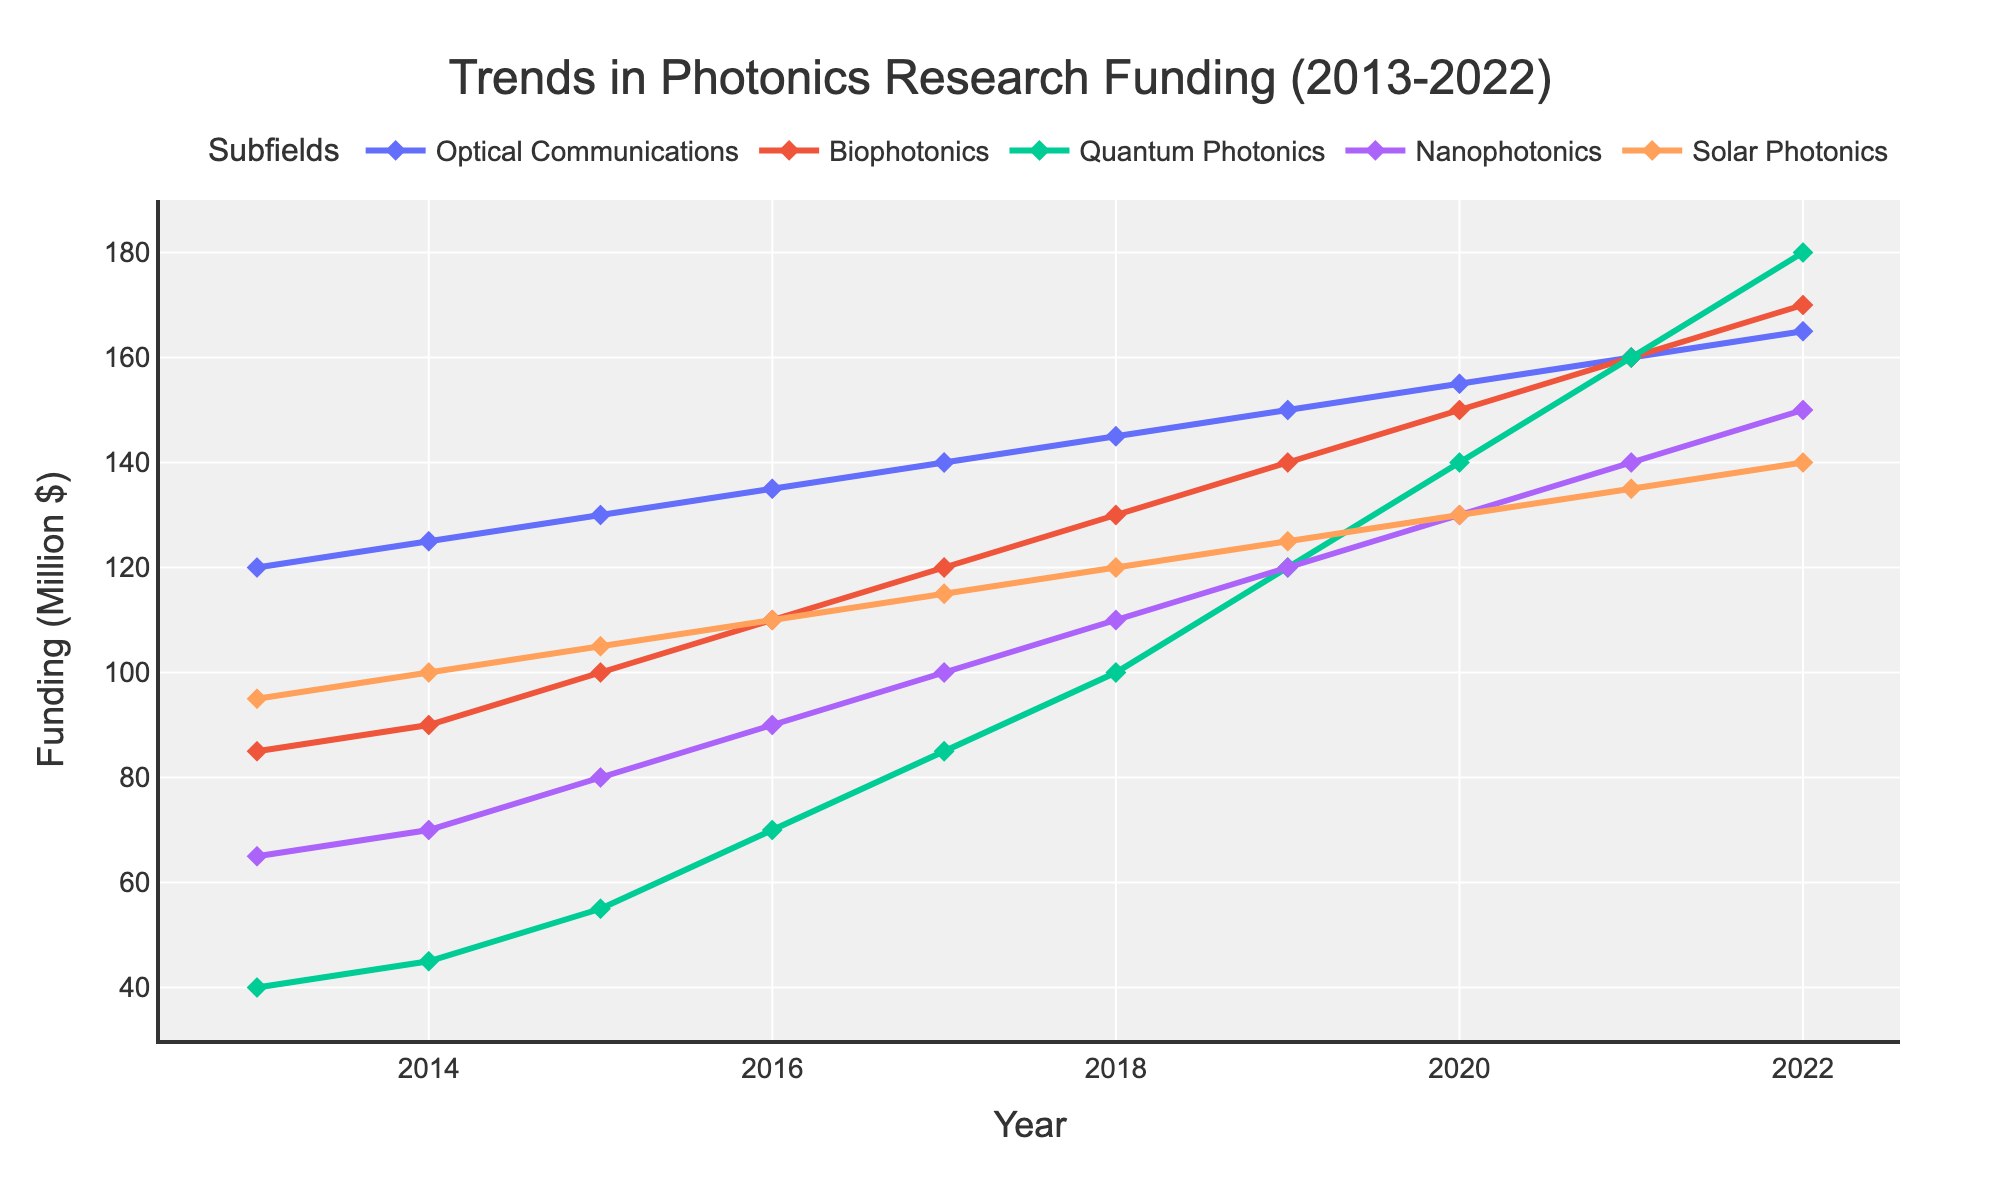Which subfield had the highest research funding in 2022? In 2022, the subfield with the highest funding can be identified by looking at the highest point on the y-axis. Quantum Photonics has the highest point at 180 million dollars.
Answer: Quantum Photonics How much did Optical Communications funding increase from 2013 to 2022? To find the increase in funding for Optical Communications from 2013 to 2022, subtract the funding in 2013 from the funding in 2022. That is 165 - 120 = 45 million dollars.
Answer: 45 million dollars What's the average funding of Biophotonics over the entire period shown? To find the average, add the funding values for Biophotonics from 2013 to 2022 and divide by the number of years (10). (85 + 90 + 100 + 110 + 120 + 130 + 140 + 150 + 160 + 170) / 10 = 125 million dollars.
Answer: 125 million dollars In which year did Solar Photonics funding surpass 120 million dollars? Check the values for Solar Photonics funding each year to see when it first exceeds 120. In 2019, the funding is 125 million dollars, which is above 120.
Answer: 2019 Did Nanophotonics funding ever exceed 130 million dollars during this period? Look at the funding values for Nanophotonics each year to check if any year has funding greater than 130. In 2022, the funding is 150 million dollars, which exceeds 130.
Answer: Yes, in 2022 Between 2017 and 2020, which subfield had the most steady increase in research funding? Compare the increase in funding for each subfield between 2017 and 2020. Optical Communications and other subfields show consistent yearly increases, but Quantum Photonics shows the steepest consistent increase, rising from 85 to 140 million dollars consistently.
Answer: Quantum Photonics Which subfield had the smallest relative increase in funding from 2013 to 2022? Calculate the relative increase for each subfield (2022 funding - 2013 funding)/2013 funding. Biophotonics has the smallest relative increase: (170 - 85)/85 = 1, or doubling, while others have higher increases.
Answer: Biophotonics Which two subfields have funding values closest to each other in the year 2020? Compare the funding values for each subfield in 2020 to find the pair with the smallest difference. Biophotonics and Quantum Photonics both have funding at 150 and 140 million dollars respectively, a difference of 10 million dollars.
Answer: Biophotonics and Quantum Photonics How did the funding of Nanophotonics change between 2015 and 2022? Subtract the funding in 2015 from the funding in 2022 for Nanophotonics: 150 - 80 = 70 million dollars.
Answer: Increased by 70 million dollars 